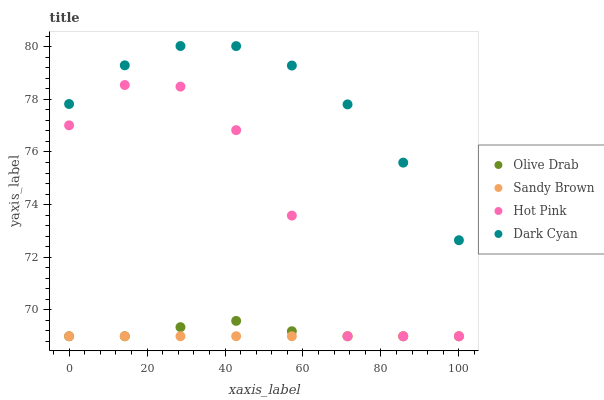Does Sandy Brown have the minimum area under the curve?
Answer yes or no. Yes. Does Dark Cyan have the maximum area under the curve?
Answer yes or no. Yes. Does Hot Pink have the minimum area under the curve?
Answer yes or no. No. Does Hot Pink have the maximum area under the curve?
Answer yes or no. No. Is Sandy Brown the smoothest?
Answer yes or no. Yes. Is Hot Pink the roughest?
Answer yes or no. Yes. Is Hot Pink the smoothest?
Answer yes or no. No. Is Sandy Brown the roughest?
Answer yes or no. No. Does Hot Pink have the lowest value?
Answer yes or no. Yes. Does Dark Cyan have the highest value?
Answer yes or no. Yes. Does Hot Pink have the highest value?
Answer yes or no. No. Is Sandy Brown less than Dark Cyan?
Answer yes or no. Yes. Is Dark Cyan greater than Sandy Brown?
Answer yes or no. Yes. Does Hot Pink intersect Sandy Brown?
Answer yes or no. Yes. Is Hot Pink less than Sandy Brown?
Answer yes or no. No. Is Hot Pink greater than Sandy Brown?
Answer yes or no. No. Does Sandy Brown intersect Dark Cyan?
Answer yes or no. No. 